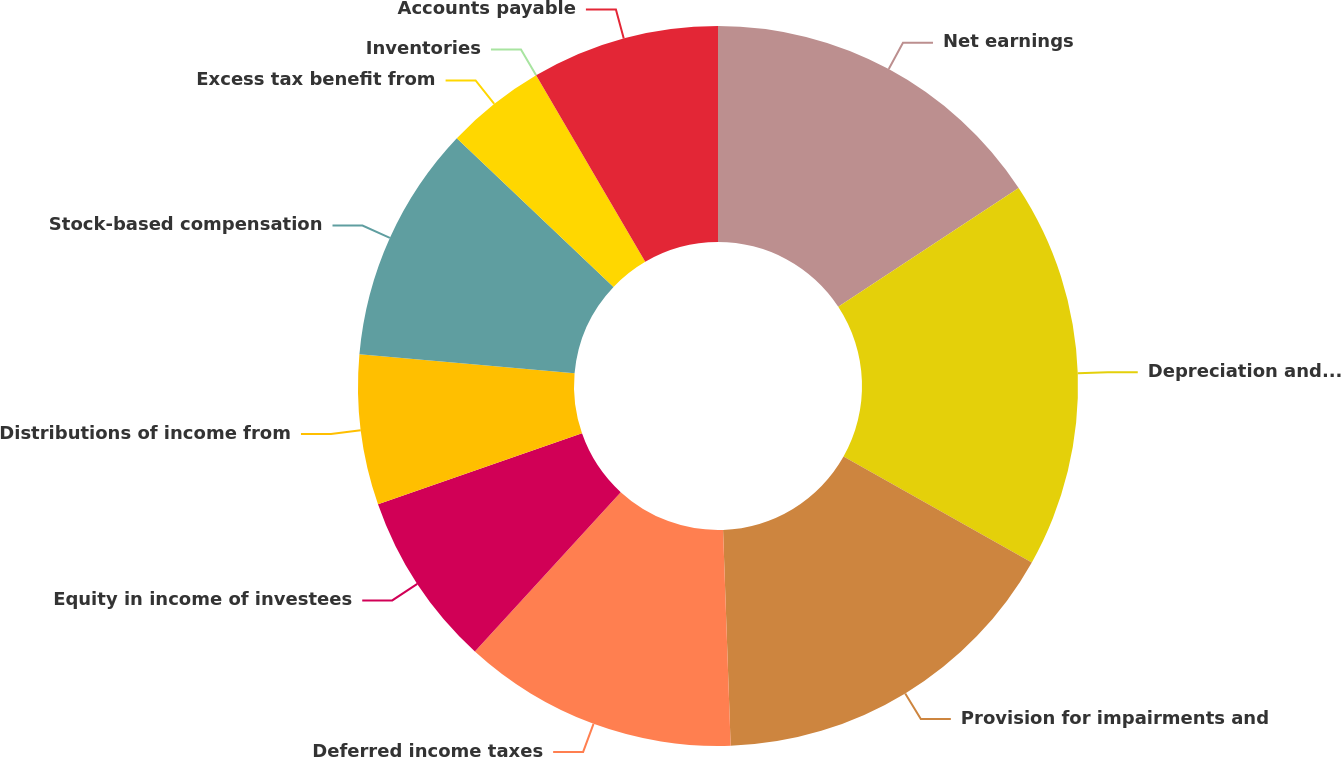Convert chart. <chart><loc_0><loc_0><loc_500><loc_500><pie_chart><fcel>Net earnings<fcel>Depreciation and amortization<fcel>Provision for impairments and<fcel>Deferred income taxes<fcel>Equity in income of investees<fcel>Distributions of income from<fcel>Stock-based compensation<fcel>Excess tax benefit from<fcel>Inventories<fcel>Accounts payable<nl><fcel>15.73%<fcel>17.42%<fcel>16.29%<fcel>12.36%<fcel>7.87%<fcel>6.74%<fcel>10.67%<fcel>4.49%<fcel>0.0%<fcel>8.43%<nl></chart> 